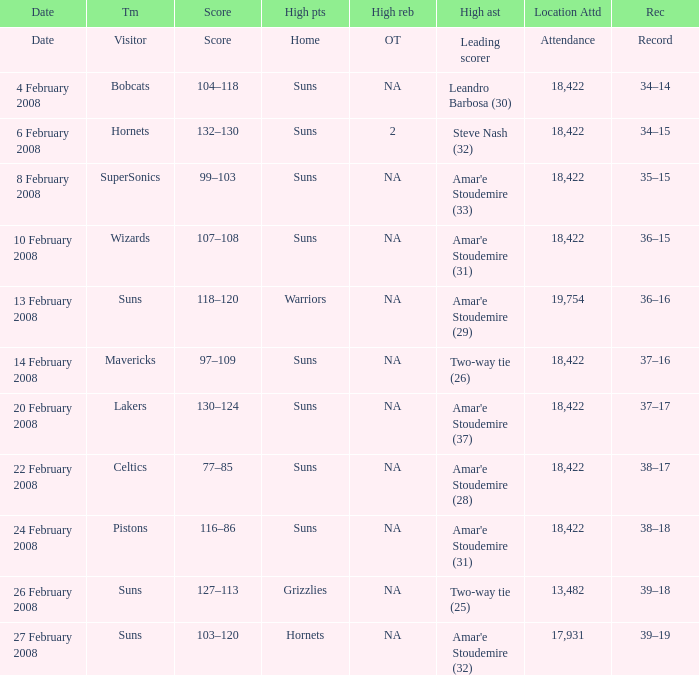How many high assists did the Lakers have? Amar'e Stoudemire (37). 